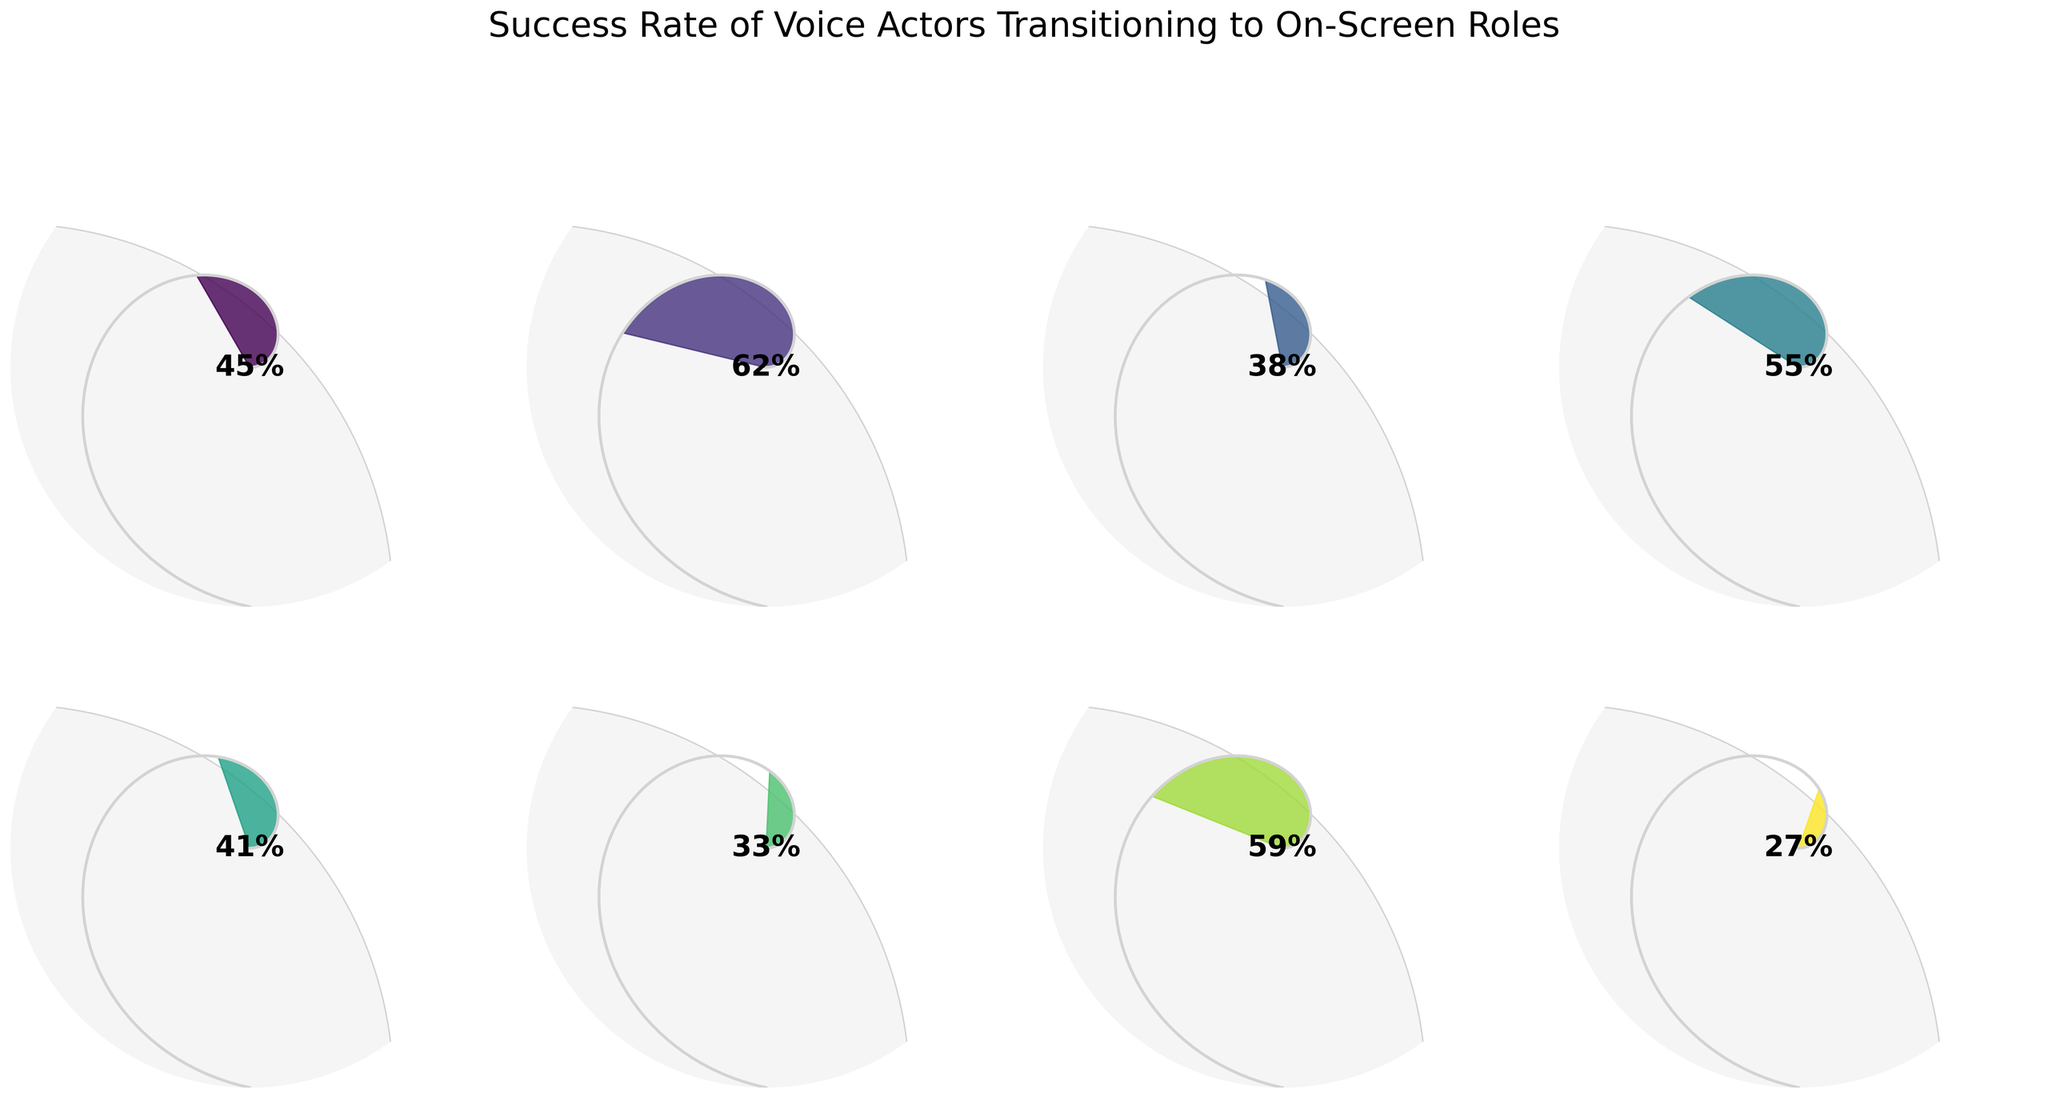What is the overall success rate of voice actors transitioning to on-screen roles? The "Overall Success Rate" gauge shows a reading of 45%, which denotes the general success rate.
Answer: 45% Which category has the highest success rate, and what is it? The "Animated to Live-Action" gauge shows a reading of 62%, which is the highest success rate among all categories.
Answer: Animated to Live-Action, 62% What is the success rate for voice actors moving from video games to television? The "Video Games to Television" gauge shows a reading of 38%.
Answer: 38% Which has a higher success rate: "Dubbing to Original Roles" or "Commercials to Film"? The success rate for "Dubbing to Original Roles" is 55% and for "Commercials to Film" is 33%. 55% is greater than 33%.
Answer: Dubbing to Original Roles What is the difference in success rates between "Anime Dub to Western Animation" and "Audiobooks to TV Series"? The success rate for "Anime Dub to Western Animation" is 59% and for "Audiobooks to TV Series" is 27%. The difference is 59% - 27% = 32%.
Answer: 32% Which category shows just above a 40% success rate? The "Voice-Only to On-Camera" gauge shows a reading of 41%, which is just above 40%.
Answer: Voice-Only to On-Camera Across all categories, what is the maximum success rate? The highest reading among all gauges is 62%, which corresponds to "Animated to Live-Action".
Answer: 62% How many categories have a success rate greater than 50%? The categories with success rates greater than 50% are: "Animated to Live-Action" (62%), "Dubbing to Original Roles" (55%), and "Anime Dub to Western Animation" (59%). This totals to 3 categories.
Answer: 3 What is the success rate of transitioning from commercials to film? The "Commercials to Film" gauge shows a reading of 33%.
Answer: 33% Is the success rate higher for "Voice-Only to On-Camera" roles or "Video Games to Television"? The success rate for "Voice-Only to On-Camera" is 41%, while for "Video Games to Television," it is 38%. 41% is higher than 38%.
Answer: Voice-Only to On-Camera 